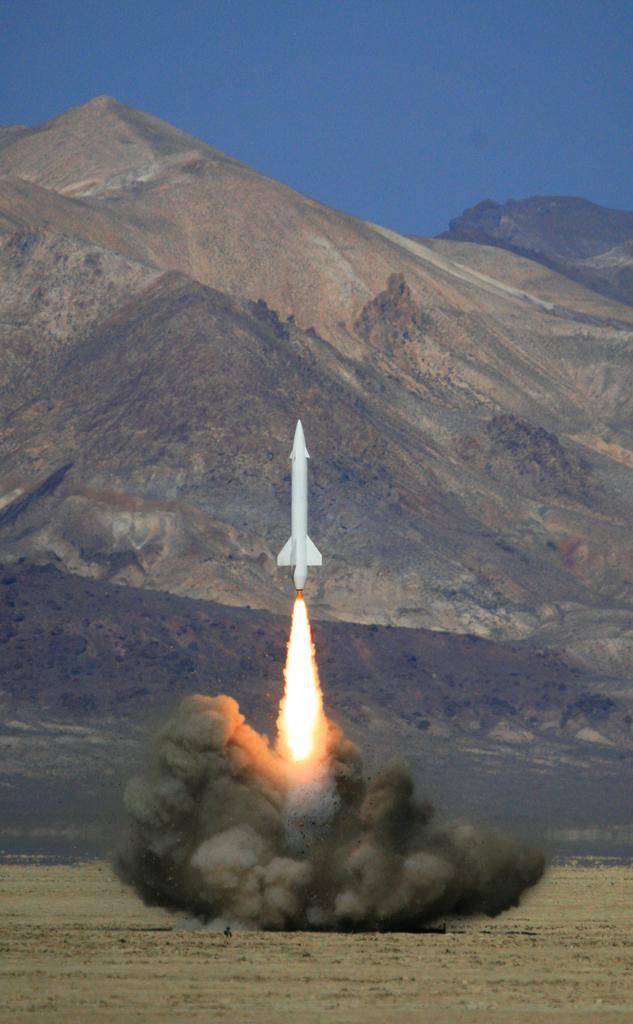How would you summarize this image in a sentence or two? In this image there is a rocket blasted off into the sky, behind the rocket there are mountains. 